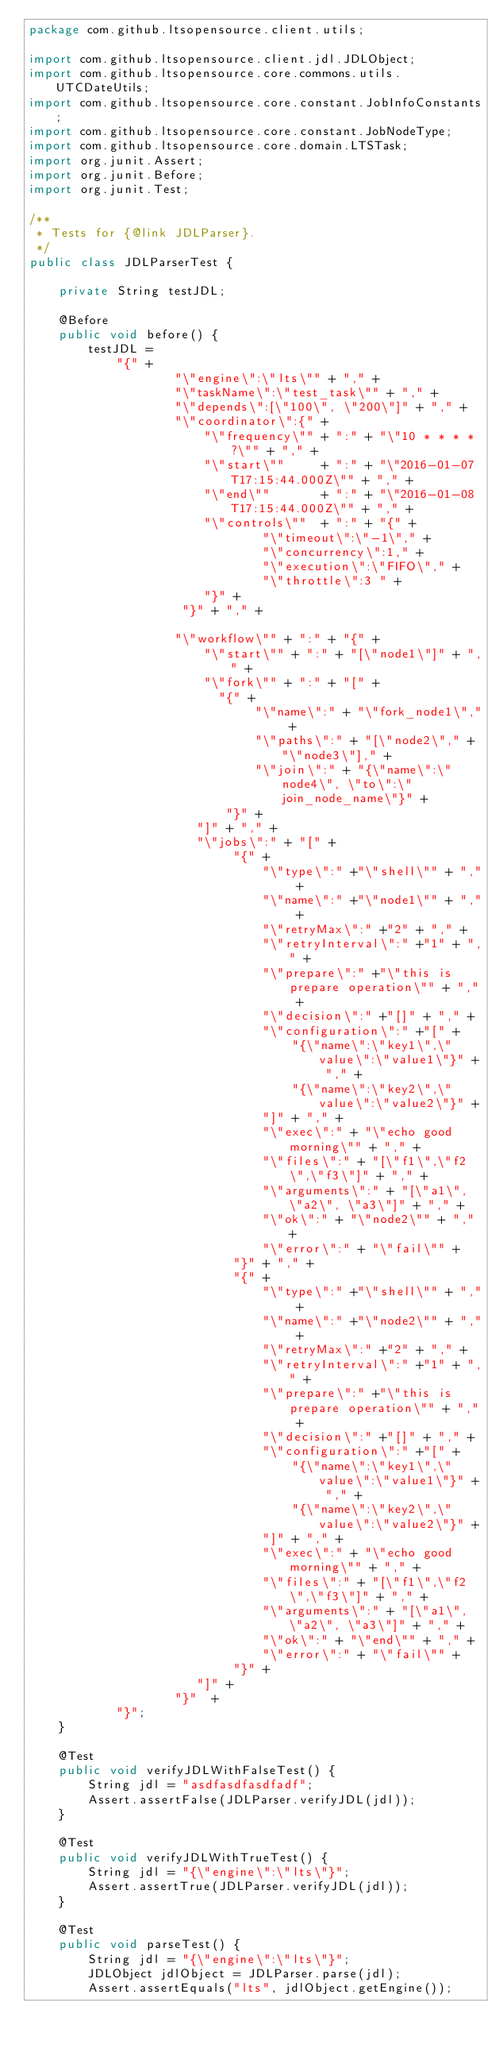Convert code to text. <code><loc_0><loc_0><loc_500><loc_500><_Java_>package com.github.ltsopensource.client.utils;

import com.github.ltsopensource.client.jdl.JDLObject;
import com.github.ltsopensource.core.commons.utils.UTCDateUtils;
import com.github.ltsopensource.core.constant.JobInfoConstants;
import com.github.ltsopensource.core.constant.JobNodeType;
import com.github.ltsopensource.core.domain.LTSTask;
import org.junit.Assert;
import org.junit.Before;
import org.junit.Test;

/**
 * Tests for {@link JDLParser}.
 */
public class JDLParserTest {

    private String testJDL;

    @Before
    public void before() {
        testJDL =
            "{" +
                    "\"engine\":\"lts\"" + "," +
                    "\"taskName\":\"test_task\"" + "," +
                    "\"depends\":[\"100\", \"200\"]" + "," +
                    "\"coordinator\":{" +
                        "\"frequency\"" + ":" + "\"10 * * * * ?\"" + "," +
                        "\"start\""     + ":" + "\"2016-01-07T17:15:44.000Z\"" + "," +
                        "\"end\""       + ":" + "\"2016-01-08T17:15:44.000Z\"" + "," +
                        "\"controls\""  + ":" + "{" +
                                "\"timeout\":\"-1\"," +
                                "\"concurrency\":1," +
                                "\"execution\":\"FIFO\"," +
                                "\"throttle\":3 " +
                        "}" +
                     "}" + "," +

                    "\"workflow\"" + ":" + "{" +
                        "\"start\"" + ":" + "[\"node1\"]" + "," +
                        "\"fork\"" + ":" + "[" +
                          "{" +
                               "\"name\":" + "\"fork_node1\"," +
                               "\"paths\":" + "[\"node2\"," + "\"node3\"]," +
                               "\"join\":" + "{\"name\":\"node4\", \"to\":\"join_node_name\"}" +
                           "}" +
                       "]" + "," +
                       "\"jobs\":" + "[" +
                            "{" +
                                "\"type\":" +"\"shell\"" + "," +
                                "\"name\":" +"\"node1\"" + "," +
                                "\"retryMax\":" +"2" + "," +
                                "\"retryInterval\":" +"1" + "," +
                                "\"prepare\":" +"\"this is prepare operation\"" + "," +
                                "\"decision\":" +"[]" + "," +
                                "\"configuration\":" +"[" +
                                    "{\"name\":\"key1\",\"value\":\"value1\"}" + "," +
                                    "{\"name\":\"key2\",\"value\":\"value2\"}" +
                                "]" + "," +
                                "\"exec\":" + "\"echo good morning\"" + "," +
                                "\"files\":" + "[\"f1\",\"f2\",\"f3\"]" + "," +
                                "\"arguments\":" + "[\"a1\", \"a2\", \"a3\"]" + "," +
                                "\"ok\":" + "\"node2\"" + "," +
                                "\"error\":" + "\"fail\"" +
                            "}" + "," +
                            "{" +
                                "\"type\":" +"\"shell\"" + "," +
                                "\"name\":" +"\"node2\"" + "," +
                                "\"retryMax\":" +"2" + "," +
                                "\"retryInterval\":" +"1" + "," +
                                "\"prepare\":" +"\"this is prepare operation\"" + "," +
                                "\"decision\":" +"[]" + "," +
                                "\"configuration\":" +"[" +
                                    "{\"name\":\"key1\",\"value\":\"value1\"}" + "," +
                                    "{\"name\":\"key2\",\"value\":\"value2\"}" +
                                "]" + "," +
                                "\"exec\":" + "\"echo good morning\"" + "," +
                                "\"files\":" + "[\"f1\",\"f2\",\"f3\"]" + "," +
                                "\"arguments\":" + "[\"a1\", \"a2\", \"a3\"]" + "," +
                                "\"ok\":" + "\"end\"" + "," +
                                "\"error\":" + "\"fail\"" +
                            "}" +
                       "]" +
                    "}"  +
            "}";
    }

    @Test
    public void verifyJDLWithFalseTest() {
        String jdl = "asdfasdfasdfadf";
        Assert.assertFalse(JDLParser.verifyJDL(jdl));
    }

    @Test
    public void verifyJDLWithTrueTest() {
        String jdl = "{\"engine\":\"lts\"}";
        Assert.assertTrue(JDLParser.verifyJDL(jdl));
    }

    @Test
    public void parseTest() {
        String jdl = "{\"engine\":\"lts\"}";
        JDLObject jdlObject = JDLParser.parse(jdl);
        Assert.assertEquals("lts", jdlObject.getEngine());
</code> 